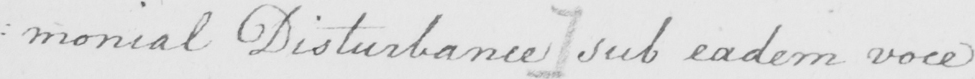Can you read and transcribe this handwriting? : monial Disturbance ]  sub eadem voce 